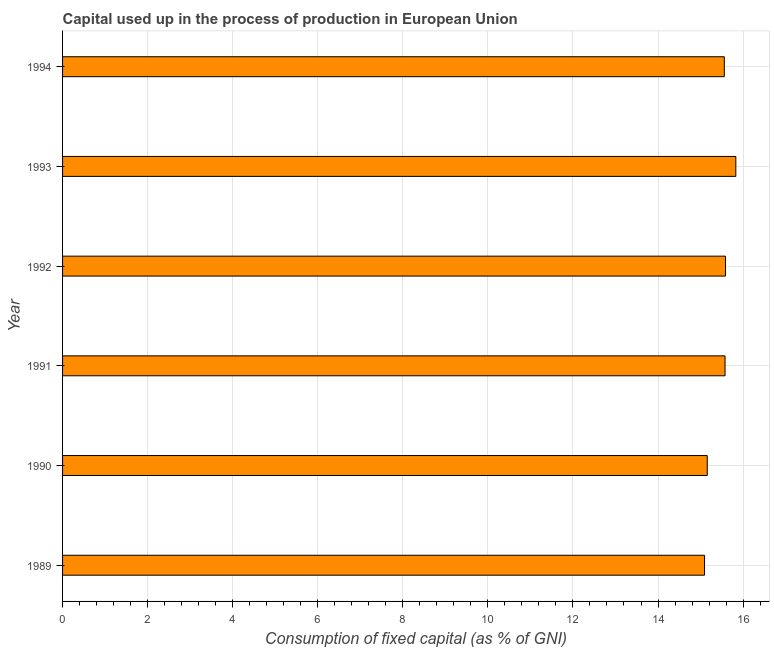Does the graph contain any zero values?
Your answer should be very brief. No. What is the title of the graph?
Keep it short and to the point. Capital used up in the process of production in European Union. What is the label or title of the X-axis?
Offer a very short reply. Consumption of fixed capital (as % of GNI). What is the consumption of fixed capital in 1994?
Make the answer very short. 15.56. Across all years, what is the maximum consumption of fixed capital?
Give a very brief answer. 15.83. Across all years, what is the minimum consumption of fixed capital?
Your answer should be compact. 15.09. In which year was the consumption of fixed capital maximum?
Offer a very short reply. 1993. What is the sum of the consumption of fixed capital?
Provide a short and direct response. 92.8. What is the difference between the consumption of fixed capital in 1989 and 1990?
Your response must be concise. -0.06. What is the average consumption of fixed capital per year?
Your answer should be compact. 15.47. What is the median consumption of fixed capital?
Your response must be concise. 15.57. Do a majority of the years between 1990 and 1992 (inclusive) have consumption of fixed capital greater than 16 %?
Provide a succinct answer. No. What is the ratio of the consumption of fixed capital in 1989 to that in 1994?
Give a very brief answer. 0.97. What is the difference between the highest and the second highest consumption of fixed capital?
Your answer should be very brief. 0.24. Is the sum of the consumption of fixed capital in 1991 and 1992 greater than the maximum consumption of fixed capital across all years?
Provide a succinct answer. Yes. What is the difference between the highest and the lowest consumption of fixed capital?
Your answer should be very brief. 0.74. How many bars are there?
Your response must be concise. 6. Are all the bars in the graph horizontal?
Provide a short and direct response. Yes. What is the difference between two consecutive major ticks on the X-axis?
Ensure brevity in your answer.  2. Are the values on the major ticks of X-axis written in scientific E-notation?
Give a very brief answer. No. What is the Consumption of fixed capital (as % of GNI) in 1989?
Your answer should be very brief. 15.09. What is the Consumption of fixed capital (as % of GNI) of 1990?
Your answer should be very brief. 15.16. What is the Consumption of fixed capital (as % of GNI) in 1991?
Ensure brevity in your answer.  15.58. What is the Consumption of fixed capital (as % of GNI) of 1992?
Your response must be concise. 15.59. What is the Consumption of fixed capital (as % of GNI) of 1993?
Your answer should be very brief. 15.83. What is the Consumption of fixed capital (as % of GNI) of 1994?
Offer a very short reply. 15.56. What is the difference between the Consumption of fixed capital (as % of GNI) in 1989 and 1990?
Offer a very short reply. -0.06. What is the difference between the Consumption of fixed capital (as % of GNI) in 1989 and 1991?
Your answer should be very brief. -0.48. What is the difference between the Consumption of fixed capital (as % of GNI) in 1989 and 1992?
Give a very brief answer. -0.49. What is the difference between the Consumption of fixed capital (as % of GNI) in 1989 and 1993?
Keep it short and to the point. -0.74. What is the difference between the Consumption of fixed capital (as % of GNI) in 1989 and 1994?
Your answer should be compact. -0.46. What is the difference between the Consumption of fixed capital (as % of GNI) in 1990 and 1991?
Give a very brief answer. -0.42. What is the difference between the Consumption of fixed capital (as % of GNI) in 1990 and 1992?
Offer a very short reply. -0.43. What is the difference between the Consumption of fixed capital (as % of GNI) in 1990 and 1993?
Make the answer very short. -0.67. What is the difference between the Consumption of fixed capital (as % of GNI) in 1990 and 1994?
Offer a very short reply. -0.4. What is the difference between the Consumption of fixed capital (as % of GNI) in 1991 and 1992?
Offer a very short reply. -0.01. What is the difference between the Consumption of fixed capital (as % of GNI) in 1991 and 1993?
Provide a succinct answer. -0.25. What is the difference between the Consumption of fixed capital (as % of GNI) in 1991 and 1994?
Give a very brief answer. 0.02. What is the difference between the Consumption of fixed capital (as % of GNI) in 1992 and 1993?
Provide a short and direct response. -0.24. What is the difference between the Consumption of fixed capital (as % of GNI) in 1992 and 1994?
Give a very brief answer. 0.03. What is the difference between the Consumption of fixed capital (as % of GNI) in 1993 and 1994?
Your answer should be compact. 0.27. What is the ratio of the Consumption of fixed capital (as % of GNI) in 1989 to that in 1992?
Keep it short and to the point. 0.97. What is the ratio of the Consumption of fixed capital (as % of GNI) in 1989 to that in 1993?
Your answer should be compact. 0.95. What is the ratio of the Consumption of fixed capital (as % of GNI) in 1990 to that in 1991?
Offer a terse response. 0.97. What is the ratio of the Consumption of fixed capital (as % of GNI) in 1990 to that in 1993?
Ensure brevity in your answer.  0.96. What is the ratio of the Consumption of fixed capital (as % of GNI) in 1991 to that in 1992?
Keep it short and to the point. 1. What is the ratio of the Consumption of fixed capital (as % of GNI) in 1991 to that in 1993?
Your response must be concise. 0.98. What is the ratio of the Consumption of fixed capital (as % of GNI) in 1991 to that in 1994?
Provide a short and direct response. 1. What is the ratio of the Consumption of fixed capital (as % of GNI) in 1992 to that in 1993?
Keep it short and to the point. 0.98. What is the ratio of the Consumption of fixed capital (as % of GNI) in 1992 to that in 1994?
Give a very brief answer. 1. 